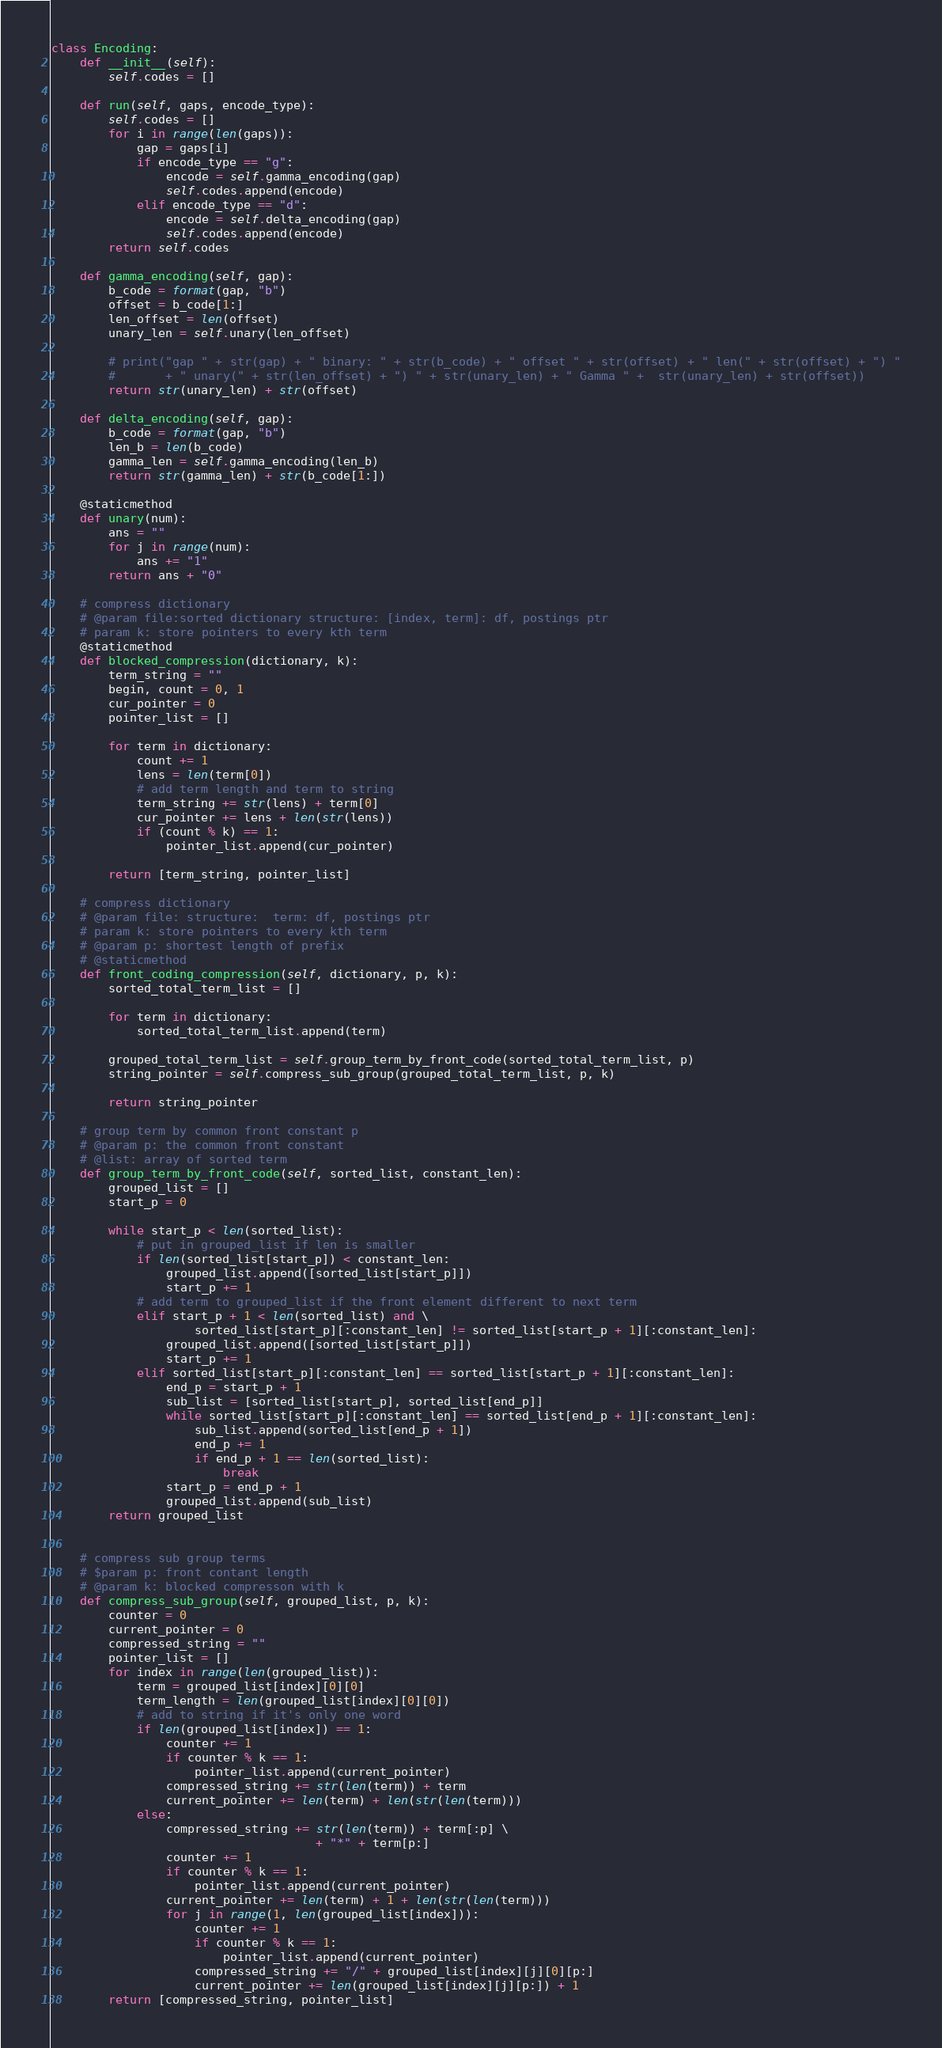<code> <loc_0><loc_0><loc_500><loc_500><_Python_>class Encoding:
    def __init__(self):
        self.codes = []

    def run(self, gaps, encode_type):
        self.codes = []
        for i in range(len(gaps)):
            gap = gaps[i]
            if encode_type == "g":
                encode = self.gamma_encoding(gap)
                self.codes.append(encode)
            elif encode_type == "d":
                encode = self.delta_encoding(gap)
                self.codes.append(encode)
        return self.codes

    def gamma_encoding(self, gap):
        b_code = format(gap, "b")
        offset = b_code[1:]
        len_offset = len(offset)
        unary_len = self.unary(len_offset)

        # print("gap " + str(gap) + " binary: " + str(b_code) + " offset " + str(offset) + " len(" + str(offset) + ") "
        #       + " unary(" + str(len_offset) + ") " + str(unary_len) + " Gamma " +  str(unary_len) + str(offset))
        return str(unary_len) + str(offset)

    def delta_encoding(self, gap):
        b_code = format(gap, "b")
        len_b = len(b_code)
        gamma_len = self.gamma_encoding(len_b)
        return str(gamma_len) + str(b_code[1:])

    @staticmethod
    def unary(num):
        ans = ""
        for j in range(num):
            ans += "1"
        return ans + "0"

    # compress dictionary
    # @param file:sorted dictionary structure: [index, term]: df, postings ptr
    # param k: store pointers to every kth term
    @staticmethod
    def blocked_compression(dictionary, k):
        term_string = ""
        begin, count = 0, 1
        cur_pointer = 0
        pointer_list = []

        for term in dictionary:
            count += 1
            lens = len(term[0])
            # add term length and term to string
            term_string += str(lens) + term[0]
            cur_pointer += lens + len(str(lens))
            if (count % k) == 1:
                pointer_list.append(cur_pointer)

        return [term_string, pointer_list]

    # compress dictionary
    # @param file: structure:  term: df, postings ptr
    # param k: store pointers to every kth term
    # @param p: shortest length of prefix
    # @staticmethod
    def front_coding_compression(self, dictionary, p, k):
        sorted_total_term_list = []

        for term in dictionary:
            sorted_total_term_list.append(term)

        grouped_total_term_list = self.group_term_by_front_code(sorted_total_term_list, p)
        string_pointer = self.compress_sub_group(grouped_total_term_list, p, k)

        return string_pointer

    # group term by common front constant p
    # @param p: the common front constant
    # @list: array of sorted term
    def group_term_by_front_code(self, sorted_list, constant_len):
        grouped_list = []
        start_p = 0

        while start_p < len(sorted_list):
            # put in grouped_list if len is smaller
            if len(sorted_list[start_p]) < constant_len:
                grouped_list.append([sorted_list[start_p]])
                start_p += 1
            # add term to grouped_list if the front element different to next term
            elif start_p + 1 < len(sorted_list) and \
                    sorted_list[start_p][:constant_len] != sorted_list[start_p + 1][:constant_len]:
                grouped_list.append([sorted_list[start_p]])
                start_p += 1
            elif sorted_list[start_p][:constant_len] == sorted_list[start_p + 1][:constant_len]:
                end_p = start_p + 1
                sub_list = [sorted_list[start_p], sorted_list[end_p]]
                while sorted_list[start_p][:constant_len] == sorted_list[end_p + 1][:constant_len]:
                    sub_list.append(sorted_list[end_p + 1])
                    end_p += 1
                    if end_p + 1 == len(sorted_list):
                        break
                start_p = end_p + 1
                grouped_list.append(sub_list)
        return grouped_list


    # compress sub group terms
    # $param p: front contant length
    # @param k: blocked compresson with k
    def compress_sub_group(self, grouped_list, p, k):
        counter = 0
        current_pointer = 0
        compressed_string = ""
        pointer_list = []
        for index in range(len(grouped_list)):
            term = grouped_list[index][0][0]
            term_length = len(grouped_list[index][0][0])
            # add to string if it's only one word
            if len(grouped_list[index]) == 1:
                counter += 1
                if counter % k == 1:
                    pointer_list.append(current_pointer)
                compressed_string += str(len(term)) + term
                current_pointer += len(term) + len(str(len(term)))
            else:
                compressed_string += str(len(term)) + term[:p] \
                                     + "*" + term[p:]
                counter += 1
                if counter % k == 1:
                    pointer_list.append(current_pointer)
                current_pointer += len(term) + 1 + len(str(len(term)))
                for j in range(1, len(grouped_list[index])):
                    counter += 1
                    if counter % k == 1:
                        pointer_list.append(current_pointer)
                    compressed_string += "/" + grouped_list[index][j][0][p:]
                    current_pointer += len(grouped_list[index][j][p:]) + 1
        return [compressed_string, pointer_list]



</code> 